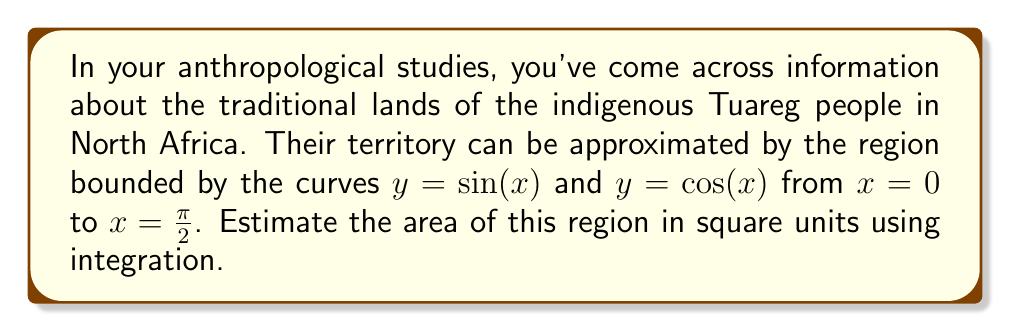Provide a solution to this math problem. To estimate the area of the region, we need to use definite integration. Here's how we can approach this problem:

1) The area between two curves is given by the integral of the difference between the upper and lower functions:

   $$A = \int_a^b [f(x) - g(x)] dx$$

   where $f(x)$ is the upper function and $g(x)$ is the lower function.

2) In this case, $\sin(x)$ is the upper function and $\cos(x)$ is the lower function in the interval $[0, \frac{\pi}{2}]$. So our integral becomes:

   $$A = \int_0^{\frac{\pi}{2}} [\sin(x) - \cos(x)] dx$$

3) We can solve this integral:

   $$A = \left[-\cos(x) - \sin(x)\right]_0^{\frac{\pi}{2}}$$

4) Now, let's evaluate the integral at the limits:

   At $x = \frac{\pi}{2}$: $-\cos(\frac{\pi}{2}) - \sin(\frac{\pi}{2}) = 0 - 1 = -1$
   
   At $x = 0$: $-\cos(0) - \sin(0) = -1 - 0 = -1$

5) The area is the difference between these values:

   $$A = (-1) - (-1) = 0$$

6) Therefore, the estimated area of the traditional Tuareg lands using this model is 0 square units.

This result might seem counterintuitive, but it's correct mathematically. In reality, this shows a limitation of our simplified model for estimating land area.
Answer: 0 square units 